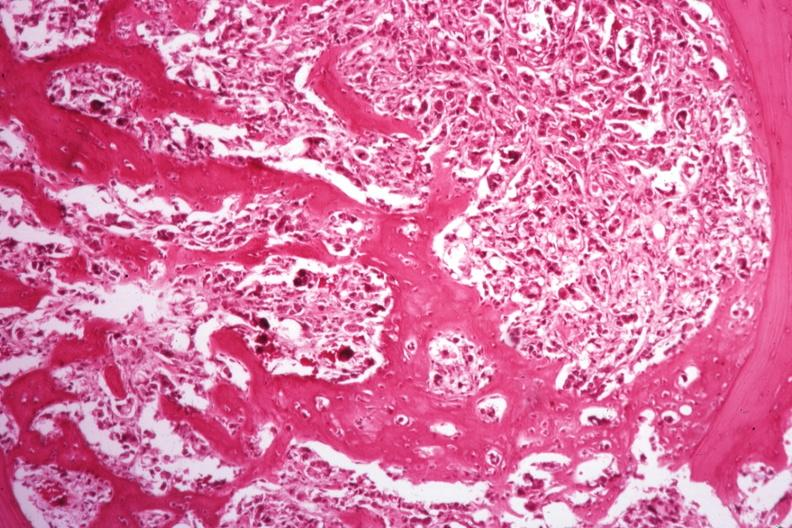does this image show islands of tumor with nice new bone formation?
Answer the question using a single word or phrase. Yes 